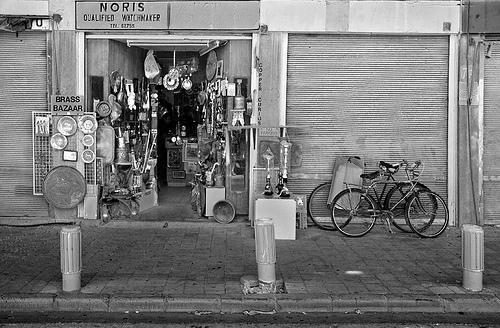How many bikes?
Give a very brief answer. 2. How many bicycles are there?
Give a very brief answer. 2. How many trucks are shown?
Give a very brief answer. 0. 